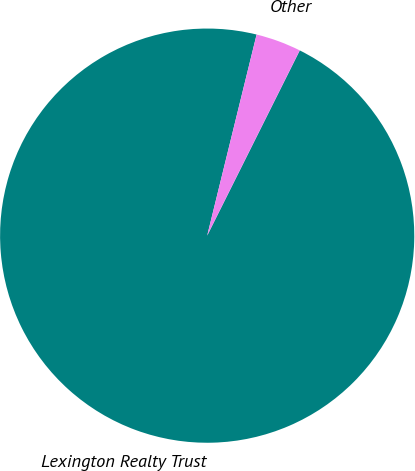Convert chart. <chart><loc_0><loc_0><loc_500><loc_500><pie_chart><fcel>Lexington Realty Trust<fcel>Other<nl><fcel>96.46%<fcel>3.54%<nl></chart> 